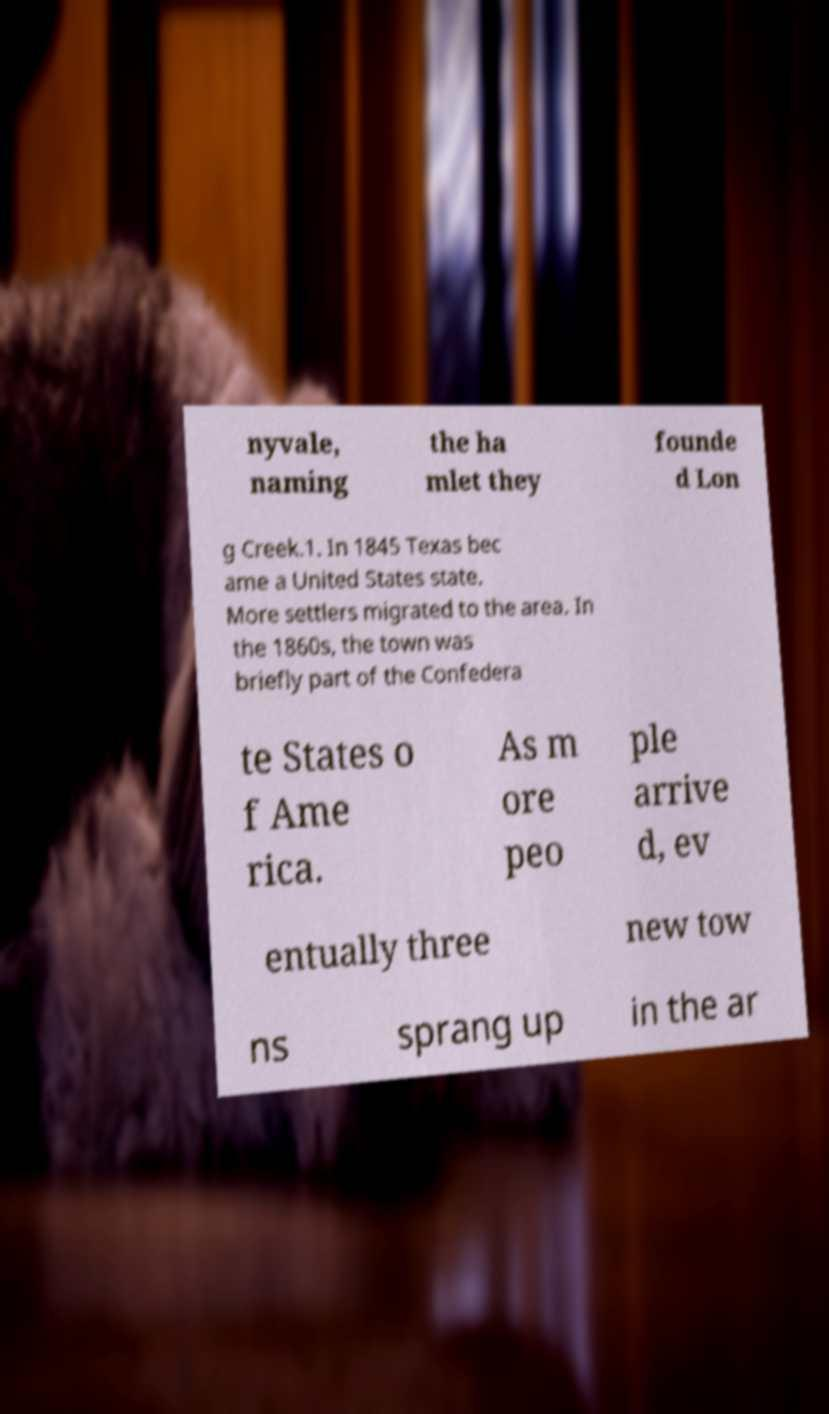Can you read and provide the text displayed in the image?This photo seems to have some interesting text. Can you extract and type it out for me? nyvale, naming the ha mlet they founde d Lon g Creek.1. In 1845 Texas bec ame a United States state. More settlers migrated to the area. In the 1860s, the town was briefly part of the Confedera te States o f Ame rica. As m ore peo ple arrive d, ev entually three new tow ns sprang up in the ar 